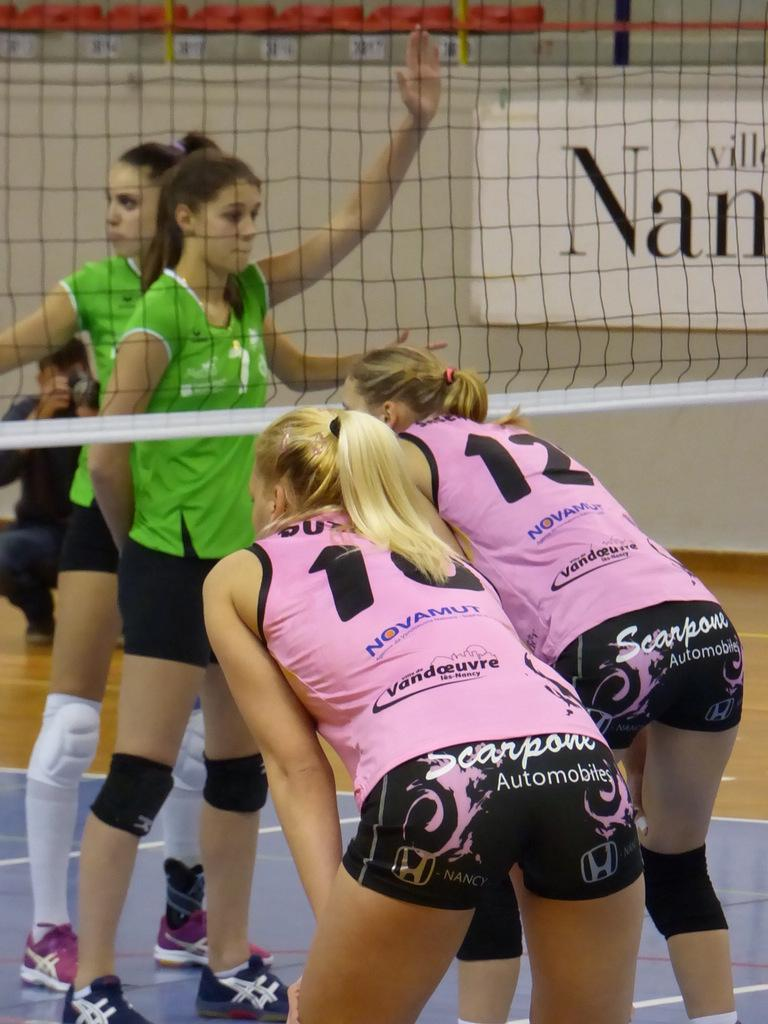Provide a one-sentence caption for the provided image. A girls volleyball game with numbers 10 and 12 on the pink team. 